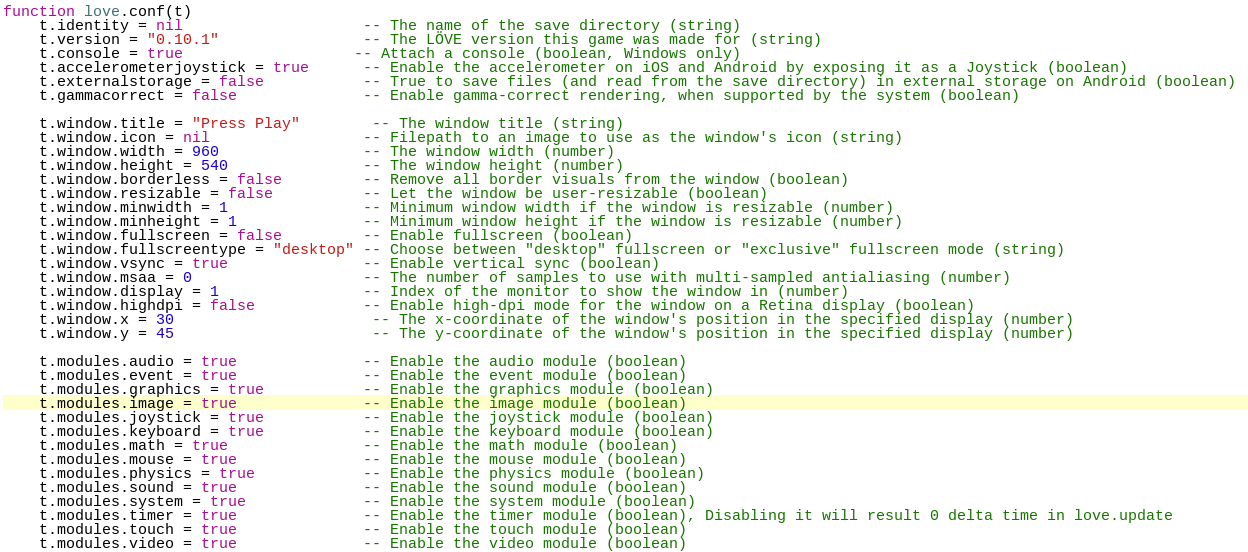<code> <loc_0><loc_0><loc_500><loc_500><_Lua_>function love.conf(t)
    t.identity = nil                    -- The name of the save directory (string)
    t.version = "0.10.1"                -- The LÖVE version this game was made for (string)
    t.console = true                   -- Attach a console (boolean, Windows only)
    t.accelerometerjoystick = true      -- Enable the accelerometer on iOS and Android by exposing it as a Joystick (boolean)
    t.externalstorage = false           -- True to save files (and read from the save directory) in external storage on Android (boolean) 
    t.gammacorrect = false              -- Enable gamma-correct rendering, when supported by the system (boolean)
 
    t.window.title = "Press Play"        -- The window title (string)
    t.window.icon = nil                 -- Filepath to an image to use as the window's icon (string)
    t.window.width = 960                -- The window width (number)
    t.window.height = 540               -- The window height (number)
    t.window.borderless = false         -- Remove all border visuals from the window (boolean)
    t.window.resizable = false          -- Let the window be user-resizable (boolean)
    t.window.minwidth = 1               -- Minimum window width if the window is resizable (number)
    t.window.minheight = 1              -- Minimum window height if the window is resizable (number)
    t.window.fullscreen = false         -- Enable fullscreen (boolean)
    t.window.fullscreentype = "desktop" -- Choose between "desktop" fullscreen or "exclusive" fullscreen mode (string)
    t.window.vsync = true               -- Enable vertical sync (boolean)
    t.window.msaa = 0                   -- The number of samples to use with multi-sampled antialiasing (number)
    t.window.display = 1                -- Index of the monitor to show the window in (number)
    t.window.highdpi = false            -- Enable high-dpi mode for the window on a Retina display (boolean)
    t.window.x = 30                      -- The x-coordinate of the window's position in the specified display (number)
    t.window.y = 45                      -- The y-coordinate of the window's position in the specified display (number)
 
    t.modules.audio = true              -- Enable the audio module (boolean)
    t.modules.event = true              -- Enable the event module (boolean)
    t.modules.graphics = true           -- Enable the graphics module (boolean)
    t.modules.image = true              -- Enable the image module (boolean)
    t.modules.joystick = true           -- Enable the joystick module (boolean)
    t.modules.keyboard = true           -- Enable the keyboard module (boolean)
    t.modules.math = true               -- Enable the math module (boolean)
    t.modules.mouse = true              -- Enable the mouse module (boolean)
    t.modules.physics = true            -- Enable the physics module (boolean)
    t.modules.sound = true              -- Enable the sound module (boolean)
    t.modules.system = true             -- Enable the system module (boolean)
    t.modules.timer = true              -- Enable the timer module (boolean), Disabling it will result 0 delta time in love.update
    t.modules.touch = true              -- Enable the touch module (boolean)
    t.modules.video = true              -- Enable the video module (boolean)</code> 